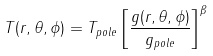<formula> <loc_0><loc_0><loc_500><loc_500>T ( r , \theta , \phi ) = T _ { p o l e } \left [ \frac { g ( r , \theta , \phi ) } { g _ { p o l e } } \right ] ^ { \beta }</formula> 